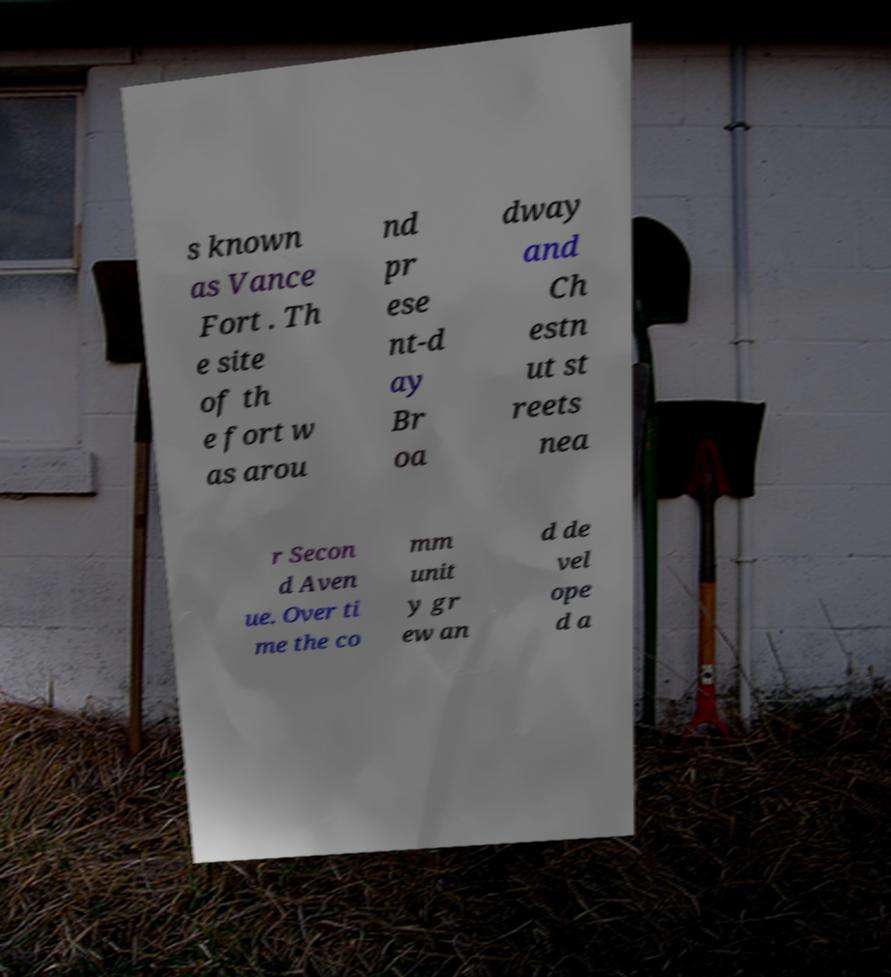I need the written content from this picture converted into text. Can you do that? s known as Vance Fort . Th e site of th e fort w as arou nd pr ese nt-d ay Br oa dway and Ch estn ut st reets nea r Secon d Aven ue. Over ti me the co mm unit y gr ew an d de vel ope d a 